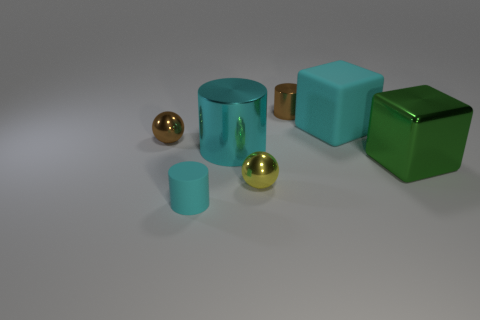Are there fewer small rubber cylinders in front of the tiny yellow shiny object than cyan matte objects that are right of the tiny brown sphere?
Your answer should be compact. Yes. The small object that is behind the large cyan metallic thing and in front of the brown shiny cylinder is made of what material?
Your response must be concise. Metal. What is the shape of the brown object that is behind the sphere that is behind the metal cube?
Your answer should be compact. Cylinder. Does the tiny matte thing have the same color as the matte cube?
Offer a very short reply. Yes. How many brown things are balls or large metallic cylinders?
Offer a very short reply. 1. Are there any large rubber blocks right of the large cyan shiny cylinder?
Offer a terse response. Yes. How big is the cyan rubber block?
Your response must be concise. Large. There is another object that is the same shape as the big cyan matte thing; what is its size?
Provide a succinct answer. Large. What number of cyan cylinders are in front of the big metal thing that is to the right of the brown shiny cylinder?
Keep it short and to the point. 1. Does the brown object right of the tiny yellow thing have the same material as the yellow thing on the left side of the large cyan rubber cube?
Offer a very short reply. Yes. 